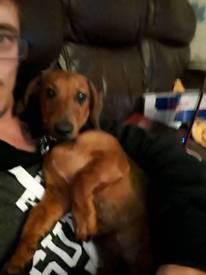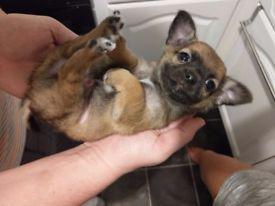The first image is the image on the left, the second image is the image on the right. Considering the images on both sides, is "A person is holding a dog in at least one of the images." valid? Answer yes or no. Yes. The first image is the image on the left, the second image is the image on the right. Assess this claim about the two images: "A human hand is holding a puppy in the air in one image, and no image contains more than one dog.". Correct or not? Answer yes or no. Yes. 